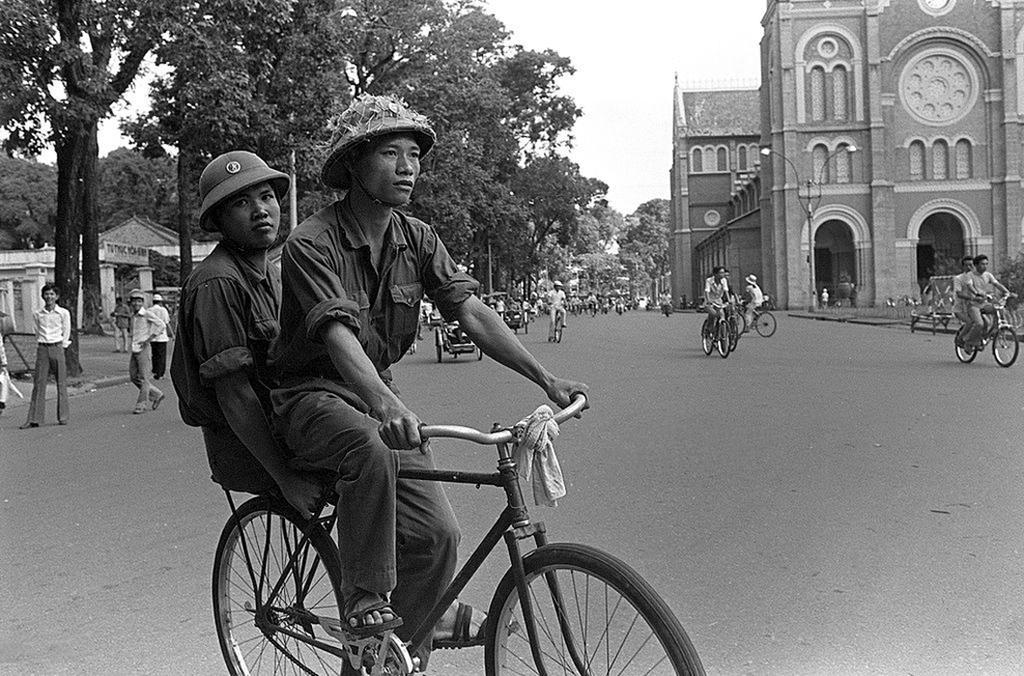How would you summarize this image in a sentence or two? In this image I see 2 persons who are on the cycle and they are on the path. In the background I see number of people who are on the cycles and some of them are standing on the path, I can also see the trees, buildings and the poles. 